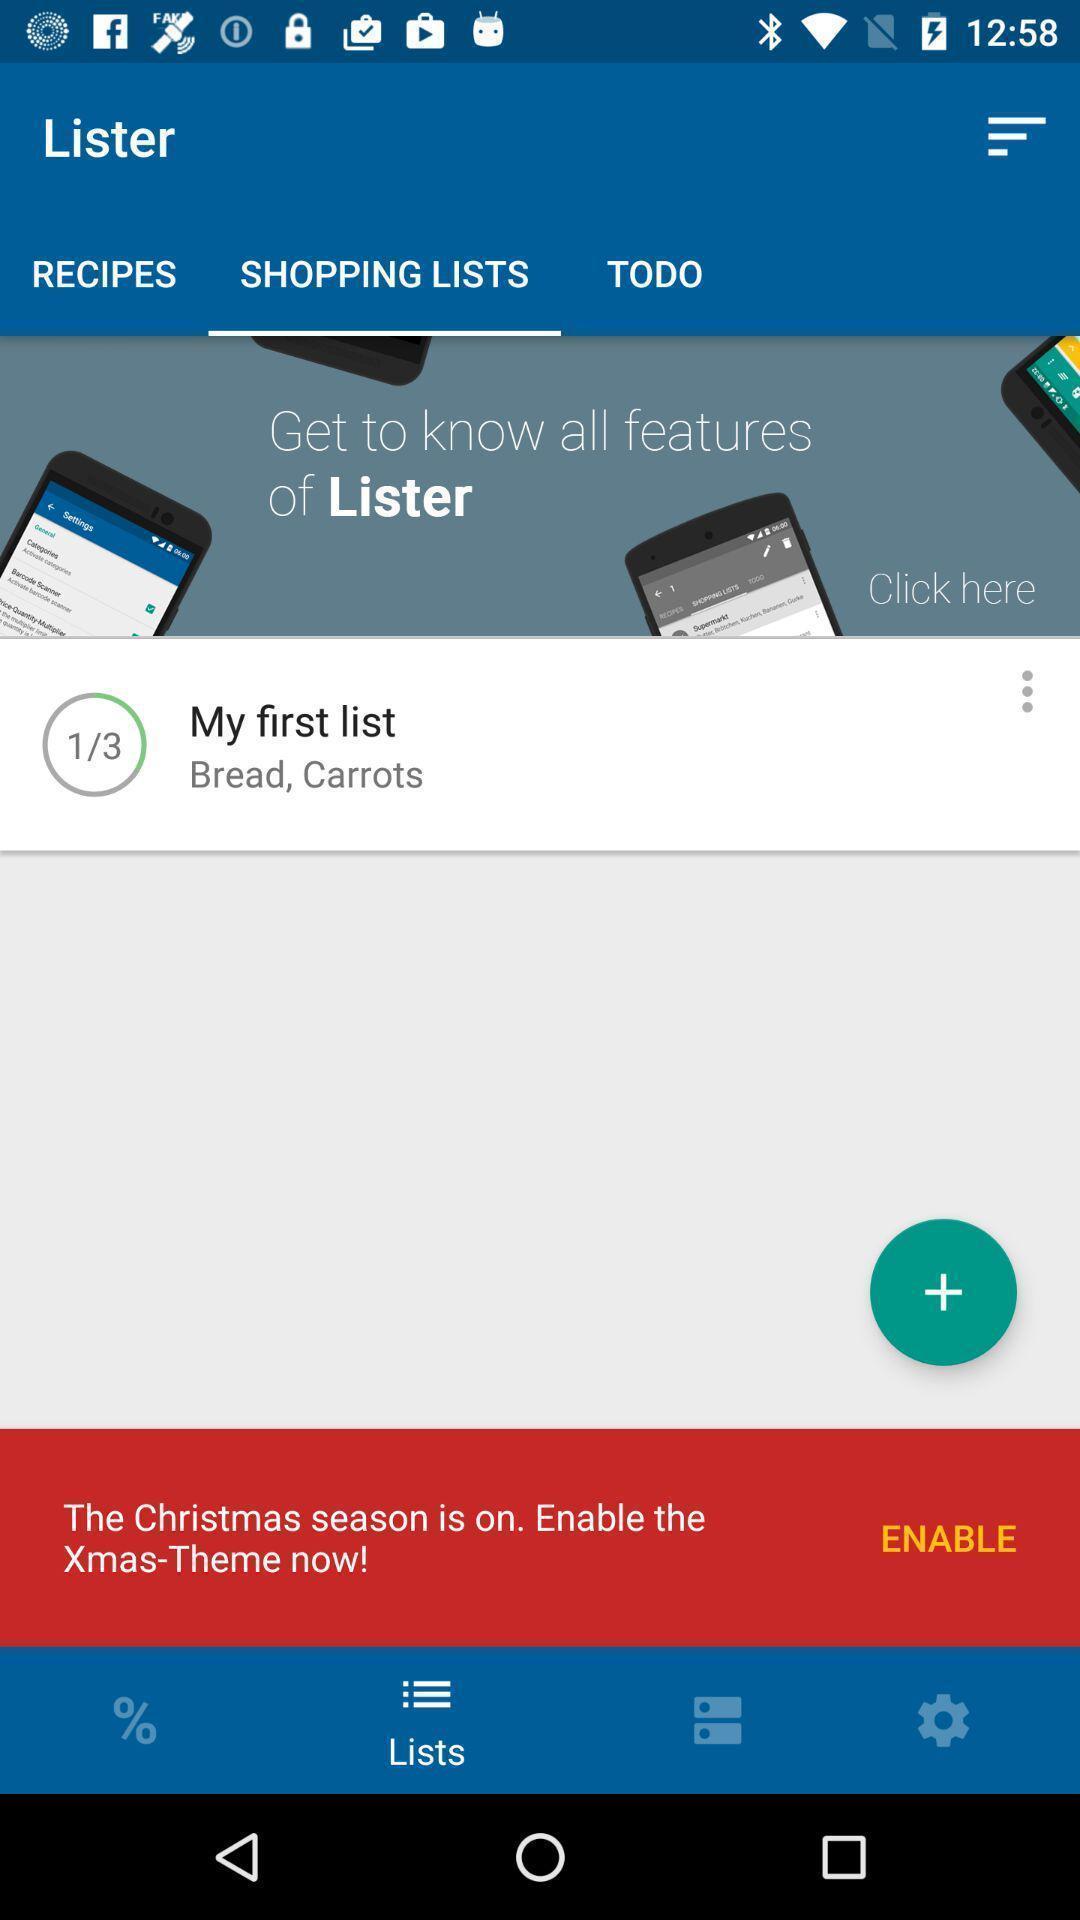Describe the content in this image. Shopping list displayed in a note app. 